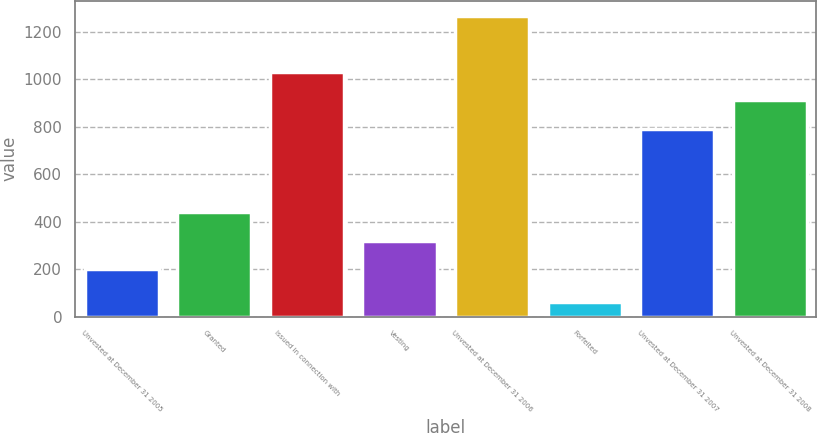Convert chart to OTSL. <chart><loc_0><loc_0><loc_500><loc_500><bar_chart><fcel>Unvested at December 31 2005<fcel>Granted<fcel>Issued in connection with<fcel>Vesting<fcel>Unvested at December 31 2006<fcel>Forfeited<fcel>Unvested at December 31 2007<fcel>Unvested at December 31 2008<nl><fcel>199<fcel>440.2<fcel>1032.2<fcel>319.6<fcel>1269<fcel>63<fcel>791<fcel>911.6<nl></chart> 